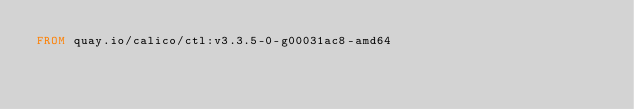<code> <loc_0><loc_0><loc_500><loc_500><_Dockerfile_>FROM quay.io/calico/ctl:v3.3.5-0-g00031ac8-amd64
</code> 